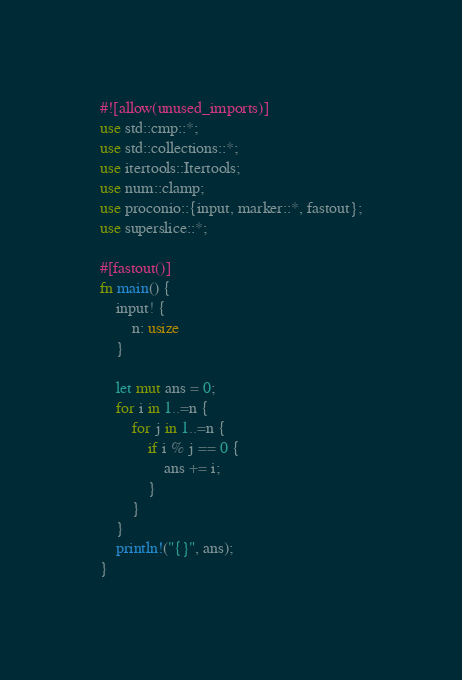Convert code to text. <code><loc_0><loc_0><loc_500><loc_500><_Rust_>#![allow(unused_imports)]
use std::cmp::*;
use std::collections::*;
use itertools::Itertools;
use num::clamp;
use proconio::{input, marker::*, fastout};
use superslice::*;

#[fastout()]
fn main() {
    input! {
        n: usize
    }

    let mut ans = 0;
    for i in 1..=n {
        for j in 1..=n {
            if i % j == 0 {
                ans += i;
            }
        }
    }
    println!("{}", ans);
}
</code> 